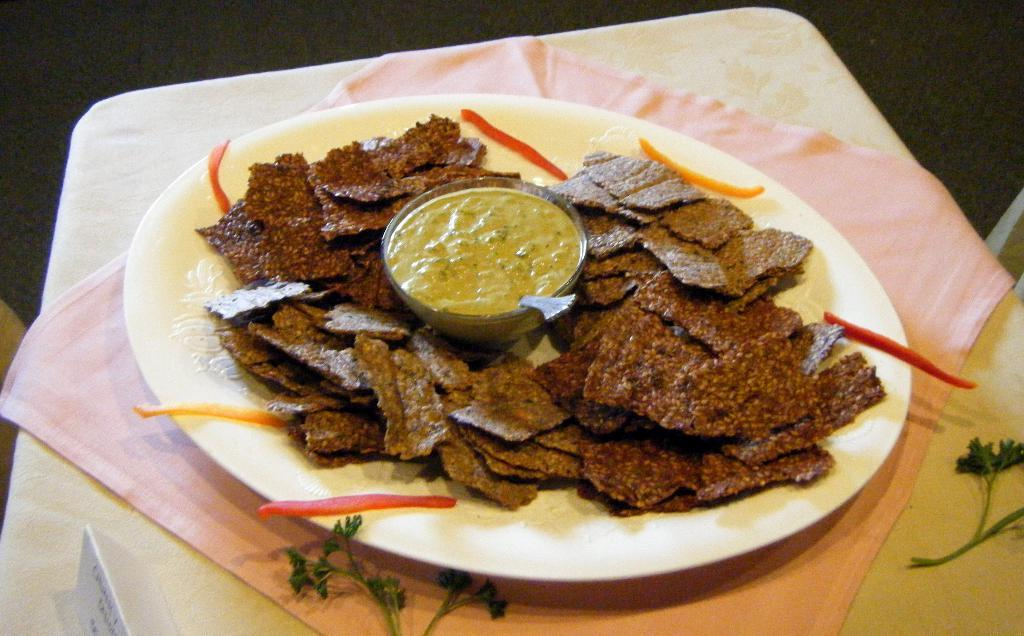What type of food can be seen in the image? There are snacks in the image. What accompanies the snacks in the image? There is sauce in the image. What utensil is present in the image? There is a spoon in the image. Where are the snacks, sauce, and spoon located? They are in a plate in the image. On what surface is the plate placed? The plate is placed on a table. What type of wound can be seen on the fairies in the image? There are no fairies present in the image, and therefore no wounds can be observed. 